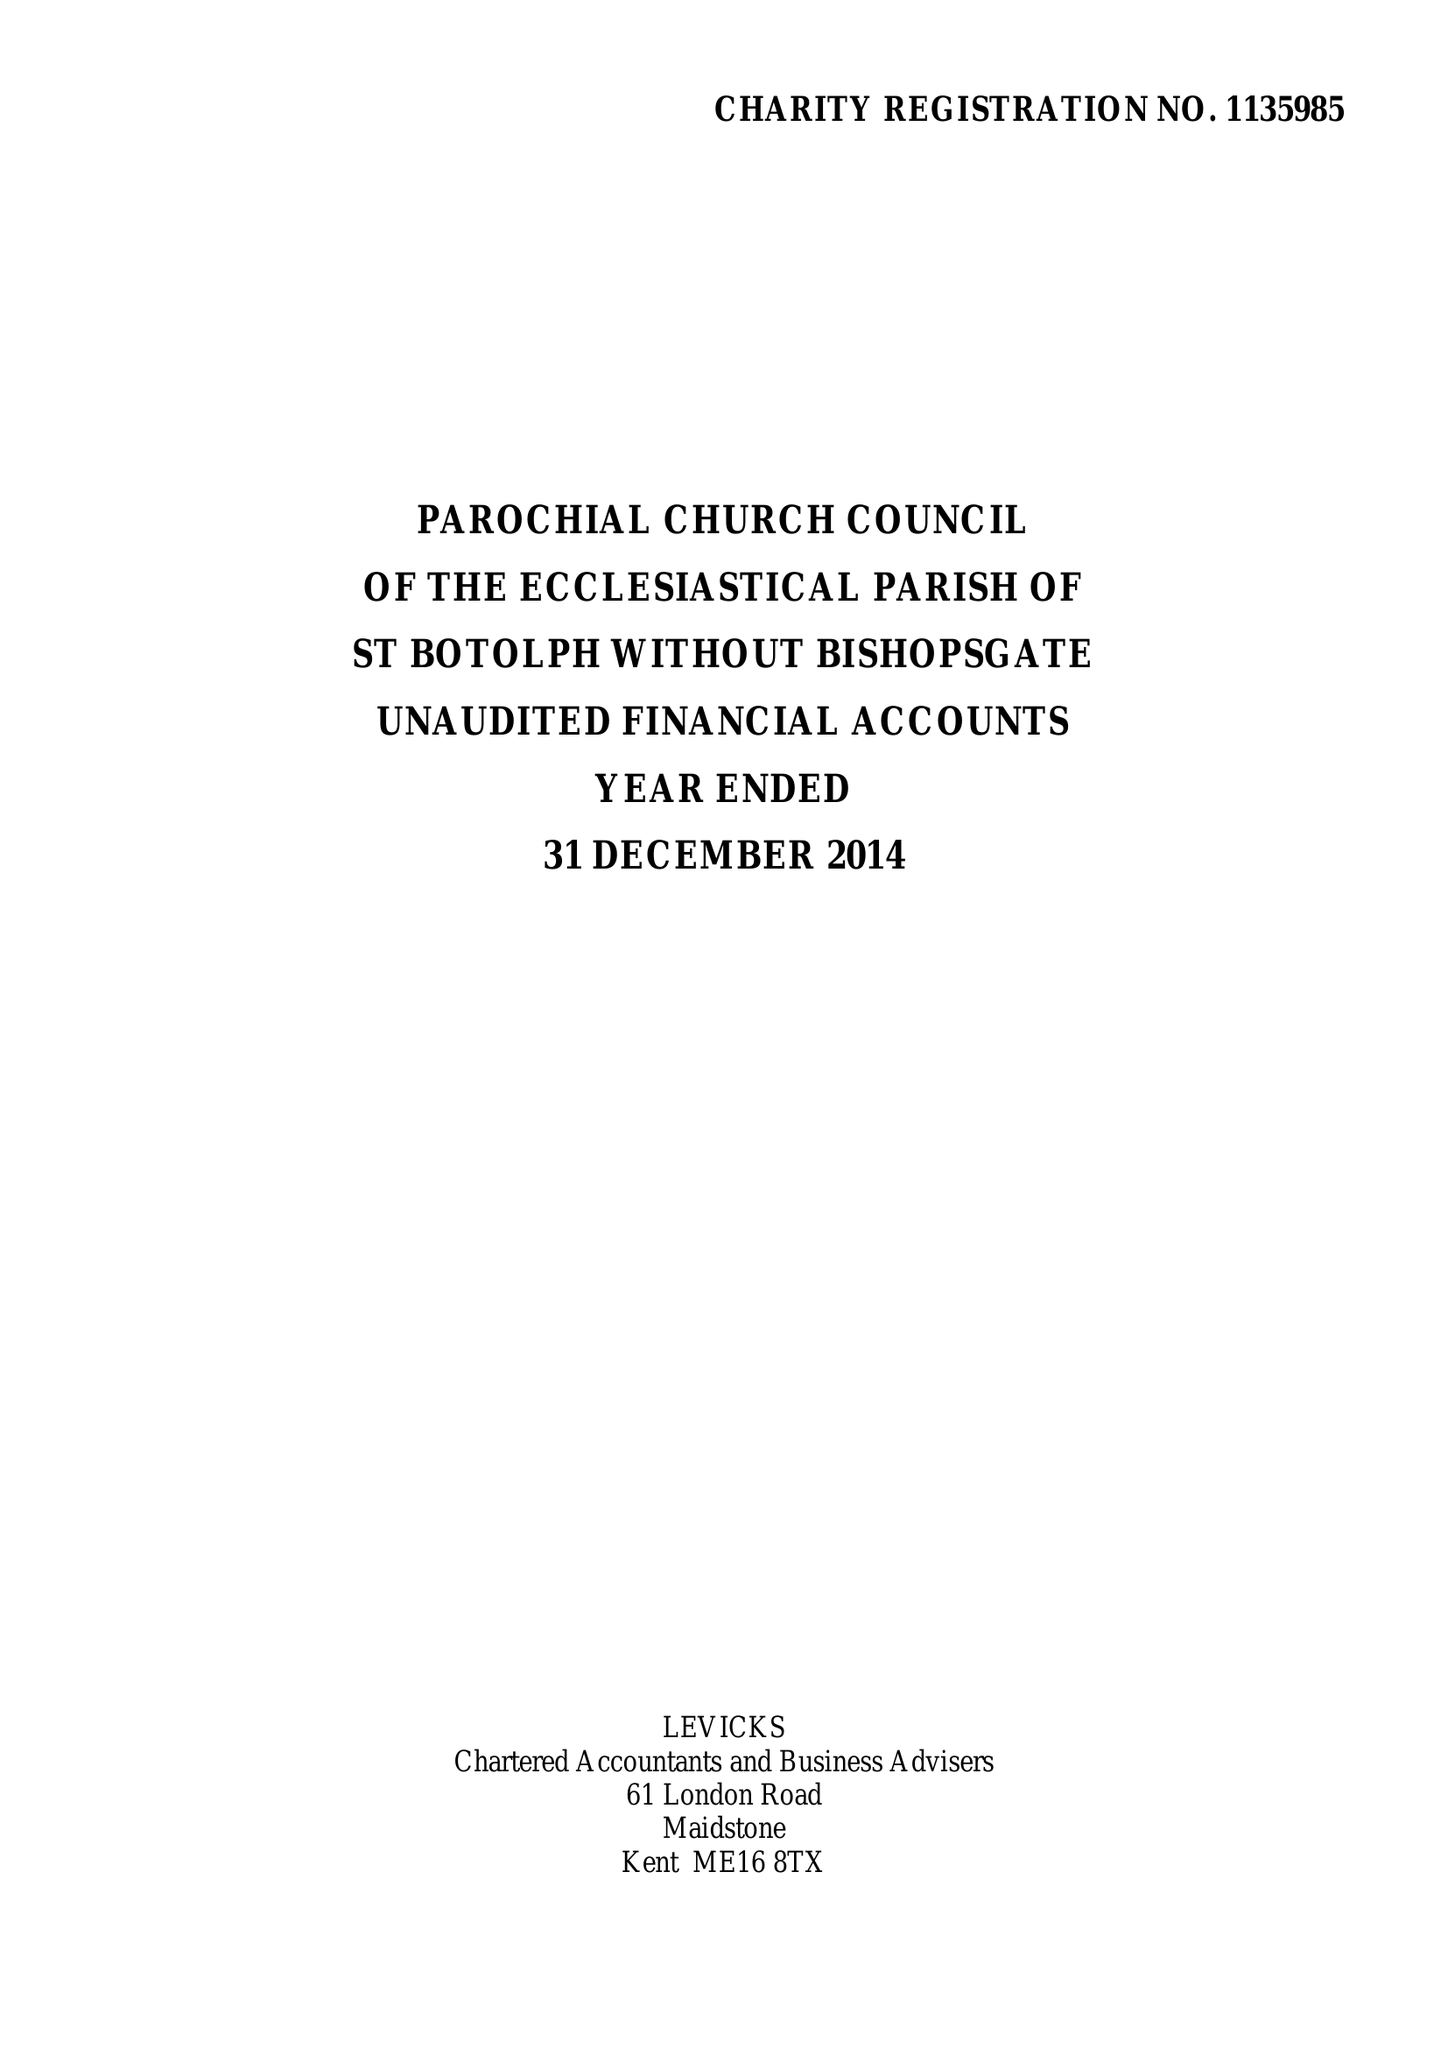What is the value for the address__post_town?
Answer the question using a single word or phrase. LONDON 